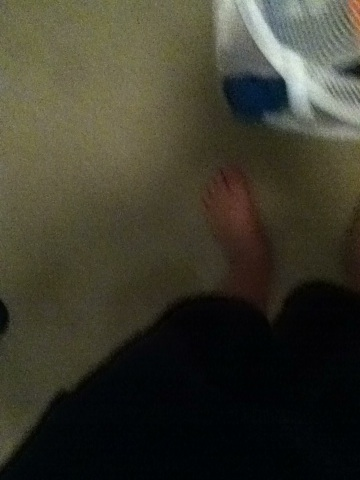What is the significance of the items in the basket? The items in the basket appear to be clothing, possibly waiting to be laundered, suggesting ordinary daily activities. The presence of personal items like these often tells a story of the everyday routines and the unseen details of an individual's life. 